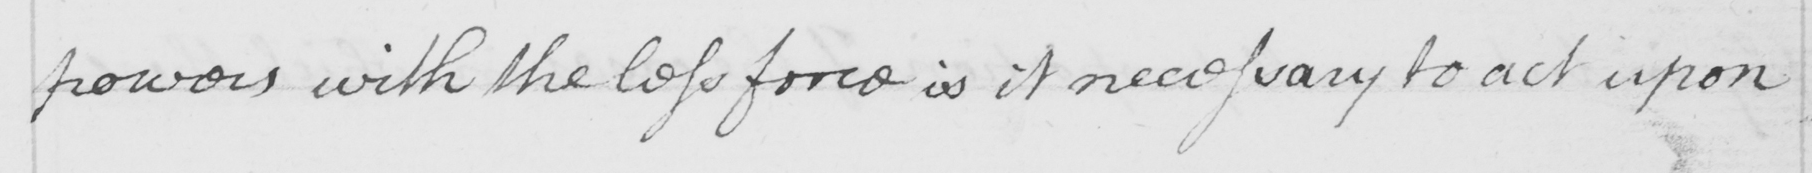What is written in this line of handwriting? powers with the less force is it necessary to act upon 